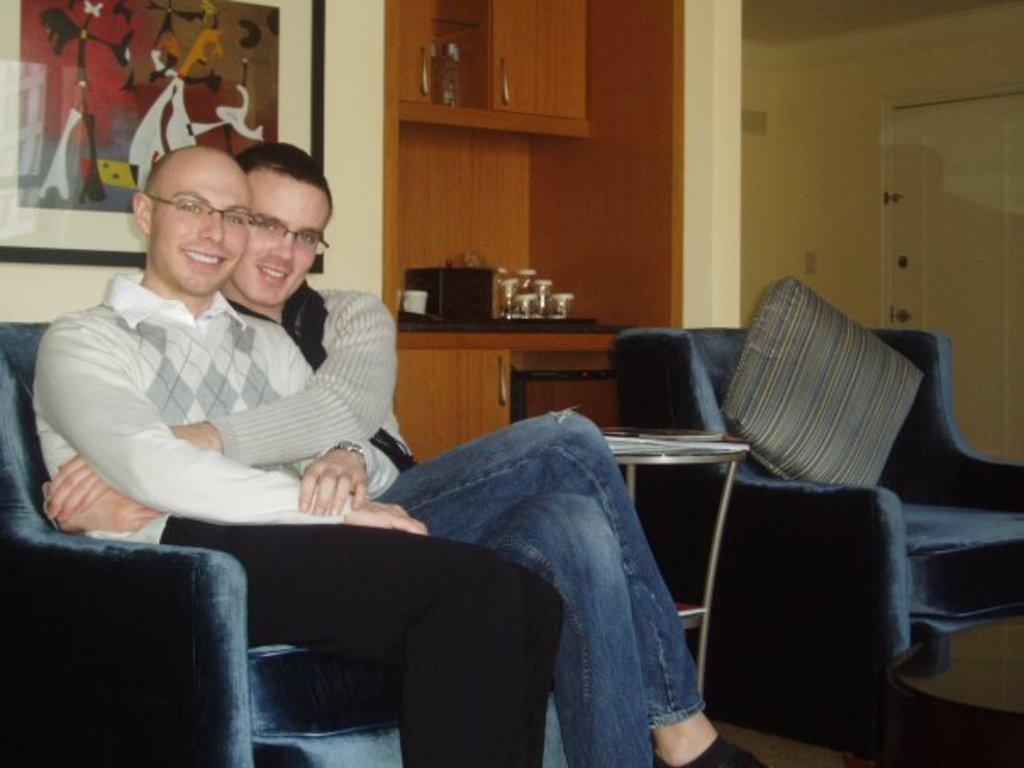In one or two sentences, can you explain what this image depicts? In this picture we can see two men wore spectacle and they are smiling and sitting on chair and beside to them we can see glasses, cup on table, pillow on sofa and we have wall, door, frame. 